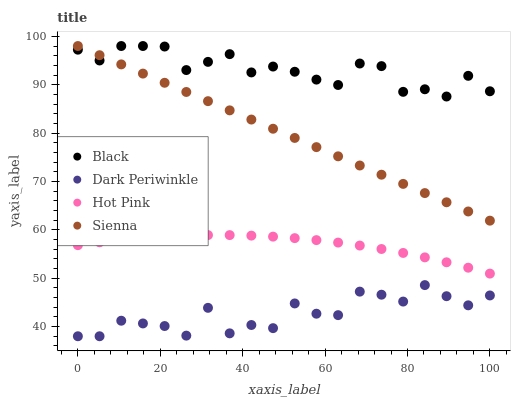Does Dark Periwinkle have the minimum area under the curve?
Answer yes or no. Yes. Does Black have the maximum area under the curve?
Answer yes or no. Yes. Does Hot Pink have the minimum area under the curve?
Answer yes or no. No. Does Hot Pink have the maximum area under the curve?
Answer yes or no. No. Is Sienna the smoothest?
Answer yes or no. Yes. Is Dark Periwinkle the roughest?
Answer yes or no. Yes. Is Hot Pink the smoothest?
Answer yes or no. No. Is Hot Pink the roughest?
Answer yes or no. No. Does Dark Periwinkle have the lowest value?
Answer yes or no. Yes. Does Hot Pink have the lowest value?
Answer yes or no. No. Does Black have the highest value?
Answer yes or no. Yes. Does Hot Pink have the highest value?
Answer yes or no. No. Is Dark Periwinkle less than Hot Pink?
Answer yes or no. Yes. Is Black greater than Dark Periwinkle?
Answer yes or no. Yes. Does Black intersect Sienna?
Answer yes or no. Yes. Is Black less than Sienna?
Answer yes or no. No. Is Black greater than Sienna?
Answer yes or no. No. Does Dark Periwinkle intersect Hot Pink?
Answer yes or no. No. 